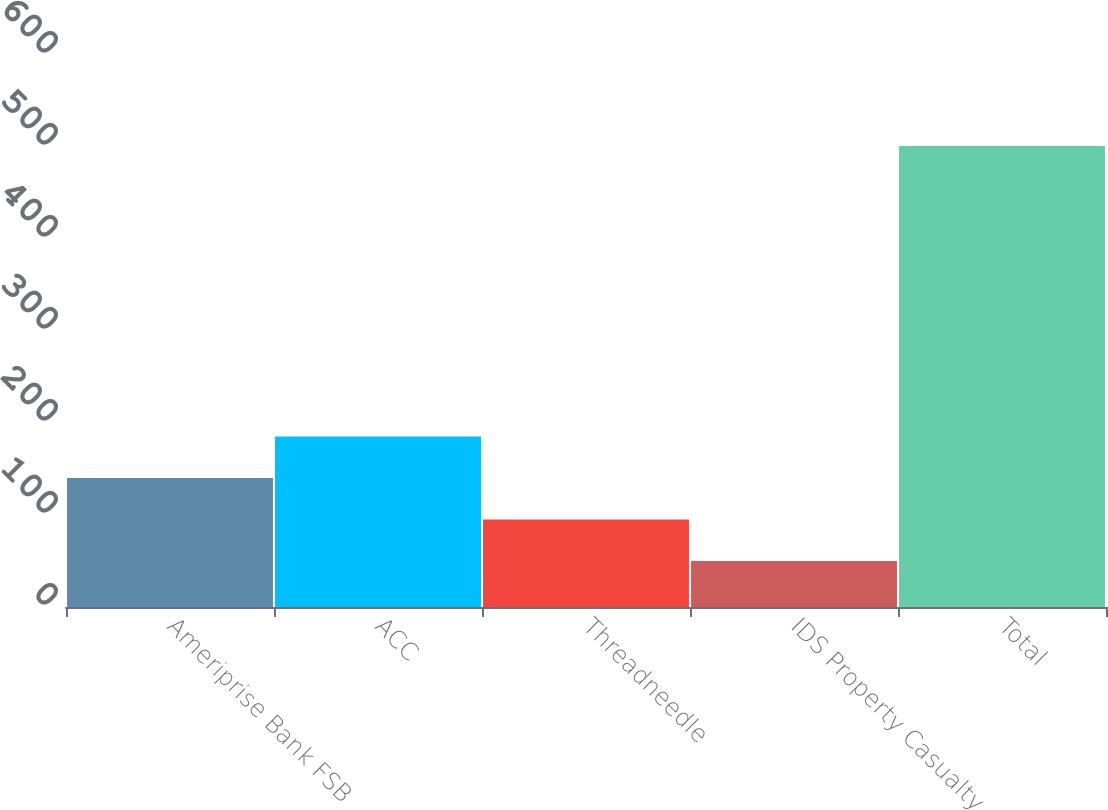<chart> <loc_0><loc_0><loc_500><loc_500><bar_chart><fcel>Ameriprise Bank FSB<fcel>ACC<fcel>Threadneedle<fcel>IDS Property Casualty<fcel>Total<nl><fcel>140.2<fcel>185.3<fcel>95.1<fcel>50<fcel>501<nl></chart> 